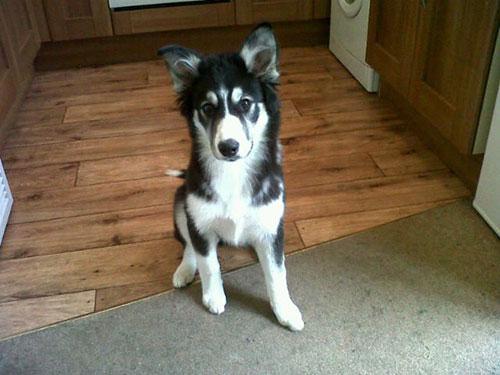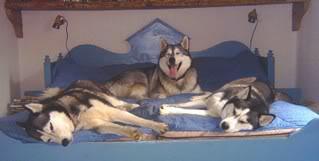The first image is the image on the left, the second image is the image on the right. Examine the images to the left and right. Is the description "In one of the images, a Malamute is near a man who is sitting on a couch." accurate? Answer yes or no. No. The first image is the image on the left, the second image is the image on the right. Examine the images to the left and right. Is the description "One image shows a single dog standing in profile, and the other image shows a man sitting on an overstuffed couch near a big dog." accurate? Answer yes or no. No. 